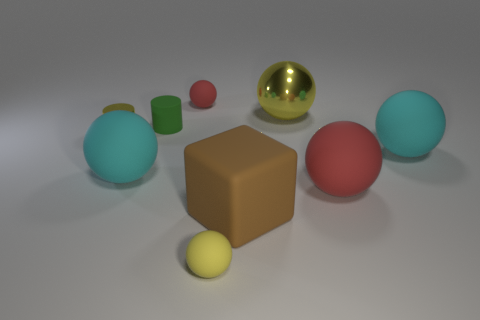Subtract all red spheres. How many spheres are left? 4 Subtract all brown cylinders. How many red spheres are left? 2 Subtract 1 balls. How many balls are left? 5 Subtract all red spheres. How many spheres are left? 4 Subtract all cylinders. How many objects are left? 7 Subtract all tiny metal objects. Subtract all large rubber blocks. How many objects are left? 7 Add 6 cylinders. How many cylinders are left? 8 Add 7 brown matte objects. How many brown matte objects exist? 8 Subtract 0 cyan cylinders. How many objects are left? 9 Subtract all yellow spheres. Subtract all green cylinders. How many spheres are left? 4 